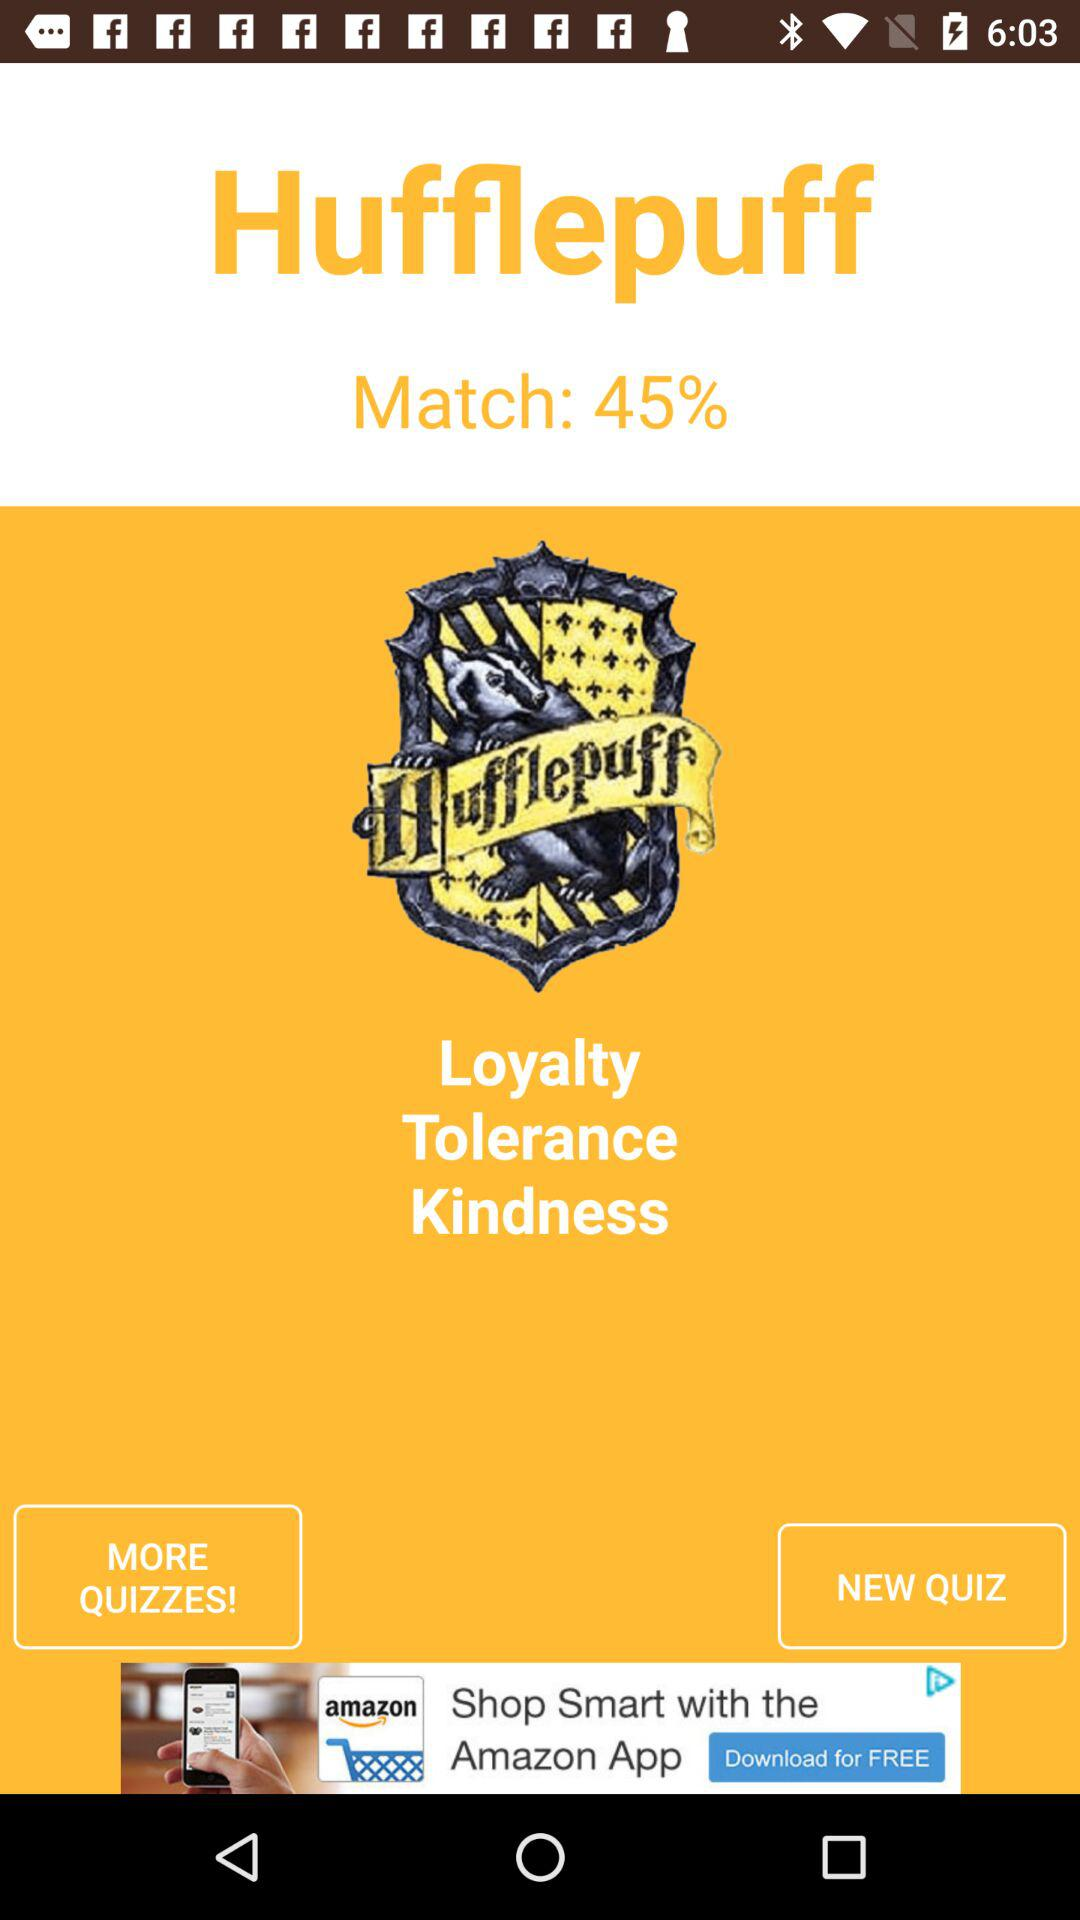What is the percentage of the match? The percentage of the match is 45. 